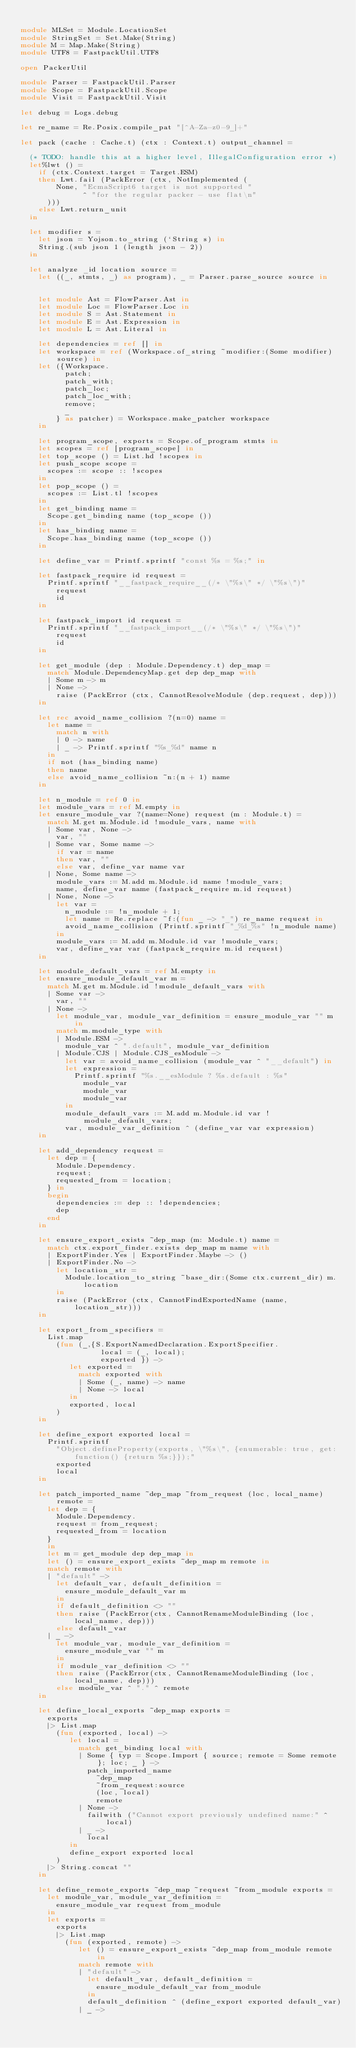<code> <loc_0><loc_0><loc_500><loc_500><_OCaml_>
module MLSet = Module.LocationSet 
module StringSet = Set.Make(String)
module M = Map.Make(String)
module UTF8 = FastpackUtil.UTF8

open PackerUtil

module Parser = FastpackUtil.Parser
module Scope = FastpackUtil.Scope
module Visit = FastpackUtil.Visit

let debug = Logs.debug

let re_name = Re.Posix.compile_pat "[^A-Za-z0-9_]+"

let pack (cache : Cache.t) (ctx : Context.t) output_channel =

  (* TODO: handle this at a higher level, IllegalConfiguration error *)
  let%lwt () =
    if (ctx.Context.target = Target.ESM)
    then Lwt.fail (PackError (ctx, NotImplemented (
        None, "EcmaScript6 target is not supported "
              ^ "for the regular packer - use flat\n"
      )))
    else Lwt.return_unit
  in

  let modifier s =
    let json = Yojson.to_string (`String s) in
    String.(sub json 1 (length json - 2))
  in

  let analyze _id location source =
    let ((_, stmts, _) as program), _ = Parser.parse_source source in


    let module Ast = FlowParser.Ast in
    let module Loc = FlowParser.Loc in
    let module S = Ast.Statement in
    let module E = Ast.Expression in
    let module L = Ast.Literal in

    let dependencies = ref [] in
    let workspace = ref (Workspace.of_string ~modifier:(Some modifier) source) in
    let ({Workspace.
          patch;
          patch_with;
          patch_loc;
          patch_loc_with;
          remove;
          _
        } as patcher) = Workspace.make_patcher workspace
    in

    let program_scope, exports = Scope.of_program stmts in
    let scopes = ref [program_scope] in
    let top_scope () = List.hd !scopes in
    let push_scope scope =
      scopes := scope :: !scopes
    in
    let pop_scope () =
      scopes := List.tl !scopes
    in
    let get_binding name =
      Scope.get_binding name (top_scope ())
    in
    let has_binding name =
      Scope.has_binding name (top_scope ())
    in

    let define_var = Printf.sprintf "const %s = %s;" in

    let fastpack_require id request =
      Printf.sprintf "__fastpack_require__(/* \"%s\" */ \"%s\")"
        request
        id
    in

    let fastpack_import id request =
      Printf.sprintf "__fastpack_import__(/* \"%s\" */ \"%s\")"
        request
        id
    in

    let get_module (dep : Module.Dependency.t) dep_map =
      match Module.DependencyMap.get dep dep_map with
      | Some m -> m
      | None ->
        raise (PackError (ctx, CannotResolveModule (dep.request, dep)))
    in

    let rec avoid_name_collision ?(n=0) name =
      let name =
        match n with
        | 0 -> name
        | _ -> Printf.sprintf "%s_%d" name n
      in
      if not (has_binding name)
      then name
      else avoid_name_collision ~n:(n + 1) name
    in

    let n_module = ref 0 in
    let module_vars = ref M.empty in
    let ensure_module_var ?(name=None) request (m : Module.t) =
      match M.get m.Module.id !module_vars, name with
      | Some var, None ->
        var, ""
      | Some var, Some name ->
        if var = name
        then var, ""
        else var, define_var name var
      | None, Some name ->
        module_vars := M.add m.Module.id name !module_vars;
        name, define_var name (fastpack_require m.id request)
      | None, None ->
        let var =
          n_module := !n_module + 1;
          let name = Re.replace ~f:(fun _ -> "_") re_name request in
          avoid_name_collision (Printf.sprintf "_%d_%s" !n_module name)
        in
        module_vars := M.add m.Module.id var !module_vars;
        var, define_var var (fastpack_require m.id request)
    in

    let module_default_vars = ref M.empty in
    let ensure_module_default_var m =
      match M.get m.Module.id !module_default_vars with
      | Some var ->
        var, ""
      | None ->
        let module_var, module_var_definition = ensure_module_var "" m in
        match m.module_type with
        | Module.ESM ->
          module_var ^ ".default", module_var_definition
        | Module.CJS | Module.CJS_esModule ->
          let var = avoid_name_collision (module_var ^ "__default") in
          let expression =
            Printf.sprintf "%s.__esModule ? %s.default : %s"
              module_var
              module_var
              module_var
          in
          module_default_vars := M.add m.Module.id var !module_default_vars;
          var, module_var_definition ^ (define_var var expression)
    in

    let add_dependency request =
      let dep = {
        Module.Dependency.
        request;
        requested_from = location;
      } in
      begin
        dependencies := dep :: !dependencies;
        dep
      end
    in

    let ensure_export_exists ~dep_map (m: Module.t) name =
      match ctx.export_finder.exists dep_map m name with
      | ExportFinder.Yes | ExportFinder.Maybe -> ()
      | ExportFinder.No ->
        let location_str =
          Module.location_to_string ~base_dir:(Some ctx.current_dir) m.location
        in
        raise (PackError (ctx, CannotFindExportedName (name, location_str)))
    in

    let export_from_specifiers =
      List.map
        (fun (_,{S.ExportNamedDeclaration.ExportSpecifier.
                  local = (_, local);
                  exported }) ->
           let exported =
             match exported with
             | Some (_, name) -> name
             | None -> local
           in
           exported, local
        )
    in

    let define_export exported local =
      Printf.sprintf
        "Object.defineProperty(exports, \"%s\", {enumerable: true, get: function() {return %s;}});"
        exported
        local
    in

    let patch_imported_name ~dep_map ~from_request (loc, local_name) remote =
      let dep = {
        Module.Dependency.
        request = from_request;
        requested_from = location
      }
      in
      let m = get_module dep dep_map in
      let () = ensure_export_exists ~dep_map m remote in
      match remote with
      | "default" ->
        let default_var, default_definition =
          ensure_module_default_var m
        in
        if default_definition <> ""
        then raise (PackError(ctx, CannotRenameModuleBinding (loc, local_name, dep)))
        else default_var
      | _ ->
        let module_var, module_var_definition =
          ensure_module_var "" m
        in
        if module_var_definition <> ""
        then raise (PackError(ctx, CannotRenameModuleBinding (loc, local_name, dep)))
        else module_var ^ "." ^ remote
    in

    let define_local_exports ~dep_map exports =
      exports
      |> List.map
        (fun (exported, local) ->
           let local =
             match get_binding local with
             | Some { typ = Scope.Import { source; remote = Some remote}; loc; _ } ->
               patch_imported_name
                 ~dep_map
                 ~from_request:source
                 (loc, local)
                 remote
             | None ->
               failwith ("Cannot export previously undefined name:" ^ local)
             | _ ->
               local
           in
           define_export exported local
        )
      |> String.concat ""
    in

    let define_remote_exports ~dep_map ~request ~from_module exports =
      let module_var, module_var_definition =
        ensure_module_var request from_module
      in
      let exports =
        exports
        |> List.map
          (fun (exported, remote) ->
             let () = ensure_export_exists ~dep_map from_module remote in
             match remote with
             | "default" ->
               let default_var, default_definition =
                 ensure_module_default_var from_module
               in
               default_definition ^ (define_export exported default_var)
             | _ -></code> 